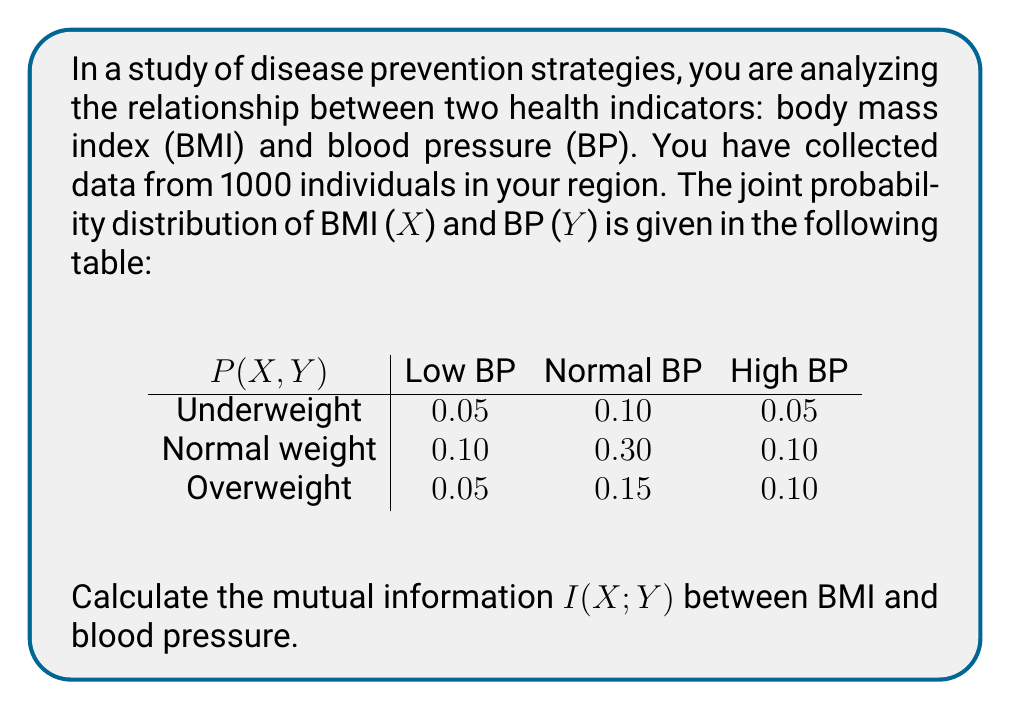Could you help me with this problem? To calculate the mutual information $I(X;Y)$, we'll follow these steps:

1) First, we need to calculate the marginal probabilities $P(X)$ and $P(Y)$:

   $P(X = \text{Underweight}) = 0.05 + 0.10 + 0.05 = 0.20$
   $P(X = \text{Normal weight}) = 0.10 + 0.30 + 0.10 = 0.50$
   $P(X = \text{Overweight}) = 0.05 + 0.15 + 0.10 = 0.30$

   $P(Y = \text{Low BP}) = 0.05 + 0.10 + 0.05 = 0.20$
   $P(Y = \text{Normal BP}) = 0.10 + 0.30 + 0.15 = 0.55$
   $P(Y = \text{High BP}) = 0.05 + 0.10 + 0.10 = 0.25$

2) The formula for mutual information is:

   $$I(X;Y) = \sum_{x \in X} \sum_{y \in Y} P(x,y) \log_2 \frac{P(x,y)}{P(x)P(y)}$$

3) Now, we'll calculate each term of the sum:

   For Underweight and Low BP:
   $0.05 \log_2 \frac{0.05}{0.20 \times 0.20} = 0.05 \log_2 1.25 = 0.0144$

   For Underweight and Normal BP:
   $0.10 \log_2 \frac{0.10}{0.20 \times 0.55} = 0.10 \log_2 0.9091 = -0.0134$

   For Underweight and High BP:
   $0.05 \log_2 \frac{0.05}{0.20 \times 0.25} = 0.05 \log_2 1 = 0$

   For Normal weight and Low BP:
   $0.10 \log_2 \frac{0.10}{0.50 \times 0.20} = 0.10 \log_2 1 = 0$

   For Normal weight and Normal BP:
   $0.30 \log_2 \frac{0.30}{0.50 \times 0.55} = 0.30 \log_2 1.0909 = 0.0358$

   For Normal weight and High BP:
   $0.10 \log_2 \frac{0.10}{0.50 \times 0.25} = 0.10 \log_2 0.8 = -0.0322$

   For Overweight and Low BP:
   $0.05 \log_2 \frac{0.05}{0.30 \times 0.20} = 0.05 \log_2 0.8333 = -0.0130$

   For Overweight and Normal BP:
   $0.15 \log_2 \frac{0.15}{0.30 \times 0.55} = 0.15 \log_2 0.9091 = -0.0201$

   For Overweight and High BP:
   $0.10 \log_2 \frac{0.10}{0.30 \times 0.25} = 0.10 \log_2 1.3333 = 0.0415$

4) Sum all these terms:

   $I(X;Y) = 0.0144 - 0.0134 + 0 + 0 + 0.0358 - 0.0322 - 0.0130 - 0.0201 + 0.0415 = 0.0130$ bits
Answer: The mutual information $I(X;Y)$ between BMI and blood pressure is approximately 0.0130 bits. 